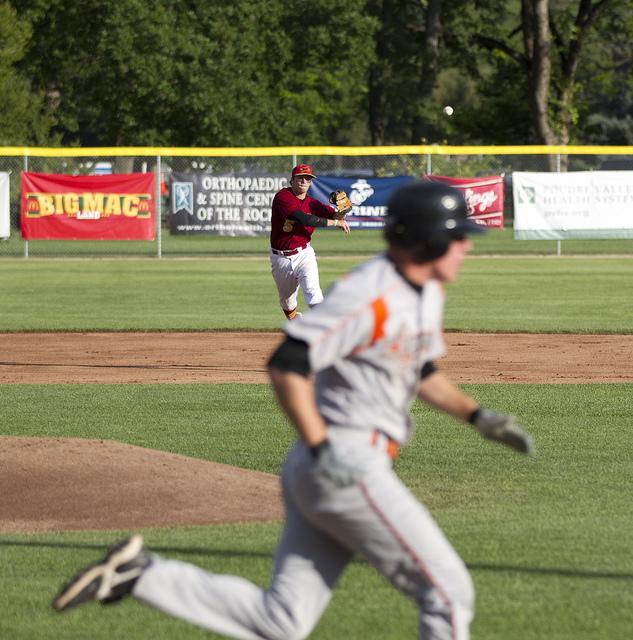What food company is represented?
Concise answer only. Mcdonald's. What color is the fence?
Give a very brief answer. Yellow. Is there a sign for McDonalds in the background?
Keep it brief. Yes. What color is the grass?
Quick response, please. Green. What sport is being played?
Answer briefly. Baseball. 